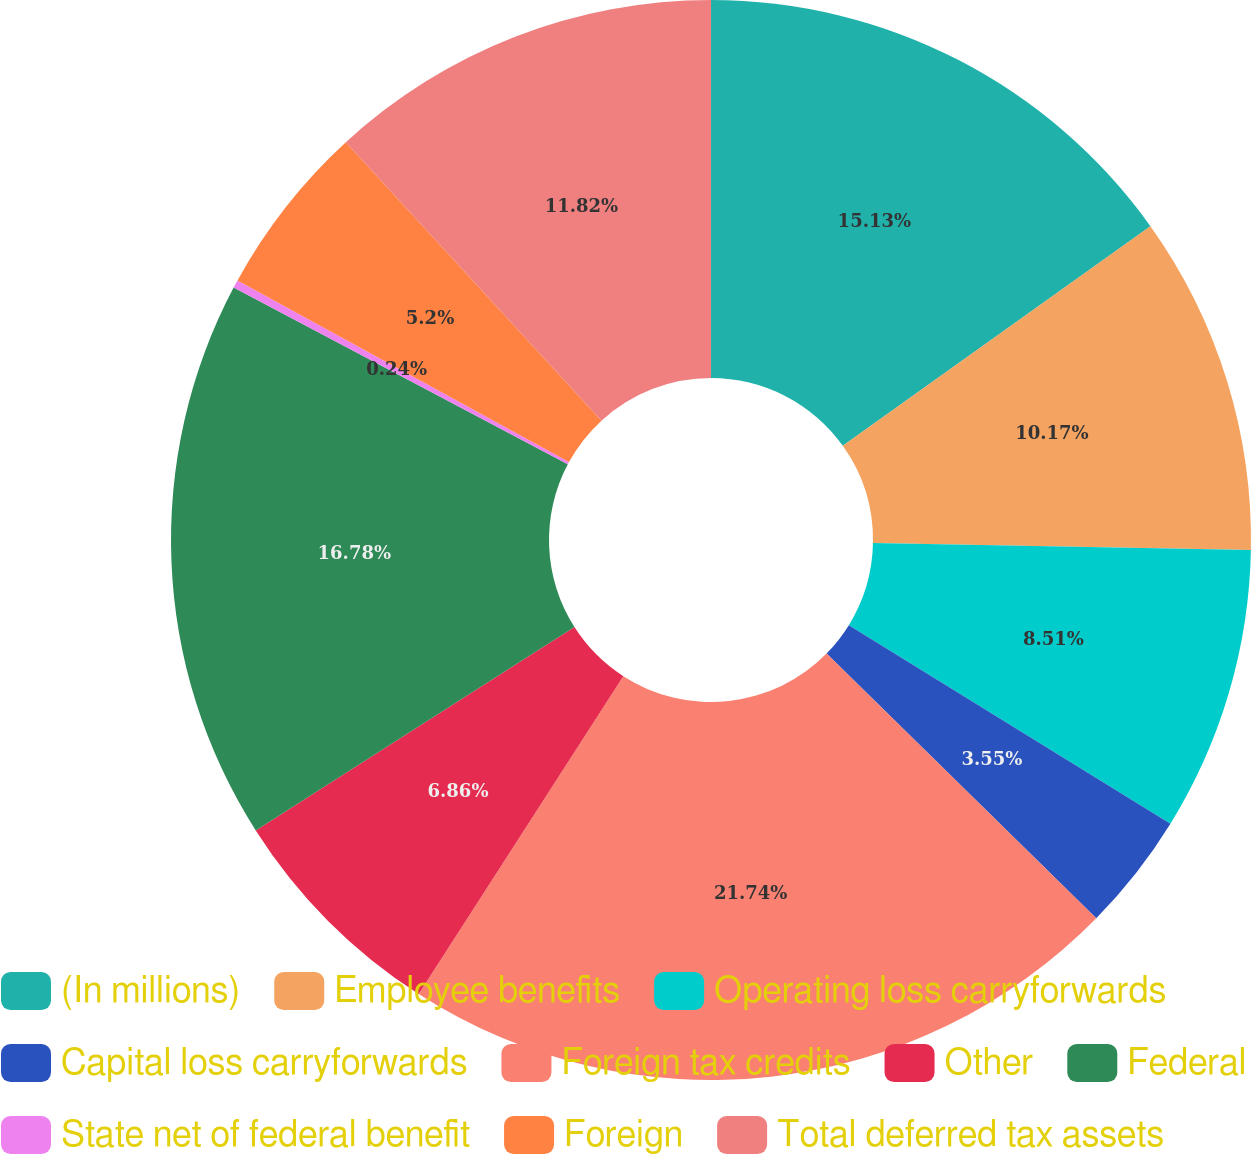Convert chart. <chart><loc_0><loc_0><loc_500><loc_500><pie_chart><fcel>(In millions)<fcel>Employee benefits<fcel>Operating loss carryforwards<fcel>Capital loss carryforwards<fcel>Foreign tax credits<fcel>Other<fcel>Federal<fcel>State net of federal benefit<fcel>Foreign<fcel>Total deferred tax assets<nl><fcel>15.13%<fcel>10.17%<fcel>8.51%<fcel>3.55%<fcel>21.75%<fcel>6.86%<fcel>16.78%<fcel>0.24%<fcel>5.2%<fcel>11.82%<nl></chart> 